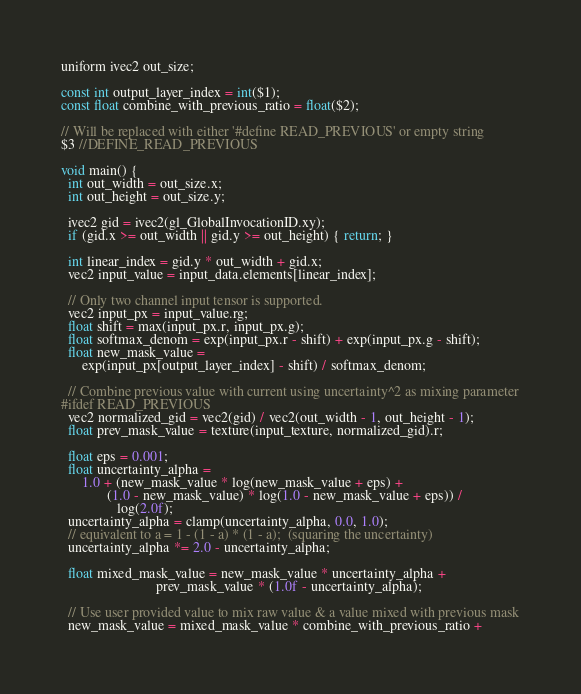Convert code to text. <code><loc_0><loc_0><loc_500><loc_500><_C++_>uniform ivec2 out_size;

const int output_layer_index = int($1);
const float combine_with_previous_ratio = float($2);

// Will be replaced with either '#define READ_PREVIOUS' or empty string
$3 //DEFINE_READ_PREVIOUS

void main() {
  int out_width = out_size.x;
  int out_height = out_size.y;

  ivec2 gid = ivec2(gl_GlobalInvocationID.xy);
  if (gid.x >= out_width || gid.y >= out_height) { return; }

  int linear_index = gid.y * out_width + gid.x;
  vec2 input_value = input_data.elements[linear_index];

  // Only two channel input tensor is supported.
  vec2 input_px = input_value.rg;
  float shift = max(input_px.r, input_px.g);
  float softmax_denom = exp(input_px.r - shift) + exp(input_px.g - shift);
  float new_mask_value =
      exp(input_px[output_layer_index] - shift) / softmax_denom;

  // Combine previous value with current using uncertainty^2 as mixing parameter
#ifdef READ_PREVIOUS
  vec2 normalized_gid = vec2(gid) / vec2(out_width - 1, out_height - 1);
  float prev_mask_value = texture(input_texture, normalized_gid).r;

  float eps = 0.001;
  float uncertainty_alpha =
      1.0 + (new_mask_value * log(new_mask_value + eps) +
             (1.0 - new_mask_value) * log(1.0 - new_mask_value + eps)) /
                log(2.0f);
  uncertainty_alpha = clamp(uncertainty_alpha, 0.0, 1.0);
  // equivalent to a = 1 - (1 - a) * (1 - a);  (squaring the uncertainty)
  uncertainty_alpha *= 2.0 - uncertainty_alpha;

  float mixed_mask_value = new_mask_value * uncertainty_alpha +
                           prev_mask_value * (1.0f - uncertainty_alpha);

  // Use user provided value to mix raw value & a value mixed with previous mask
  new_mask_value = mixed_mask_value * combine_with_previous_ratio +</code> 